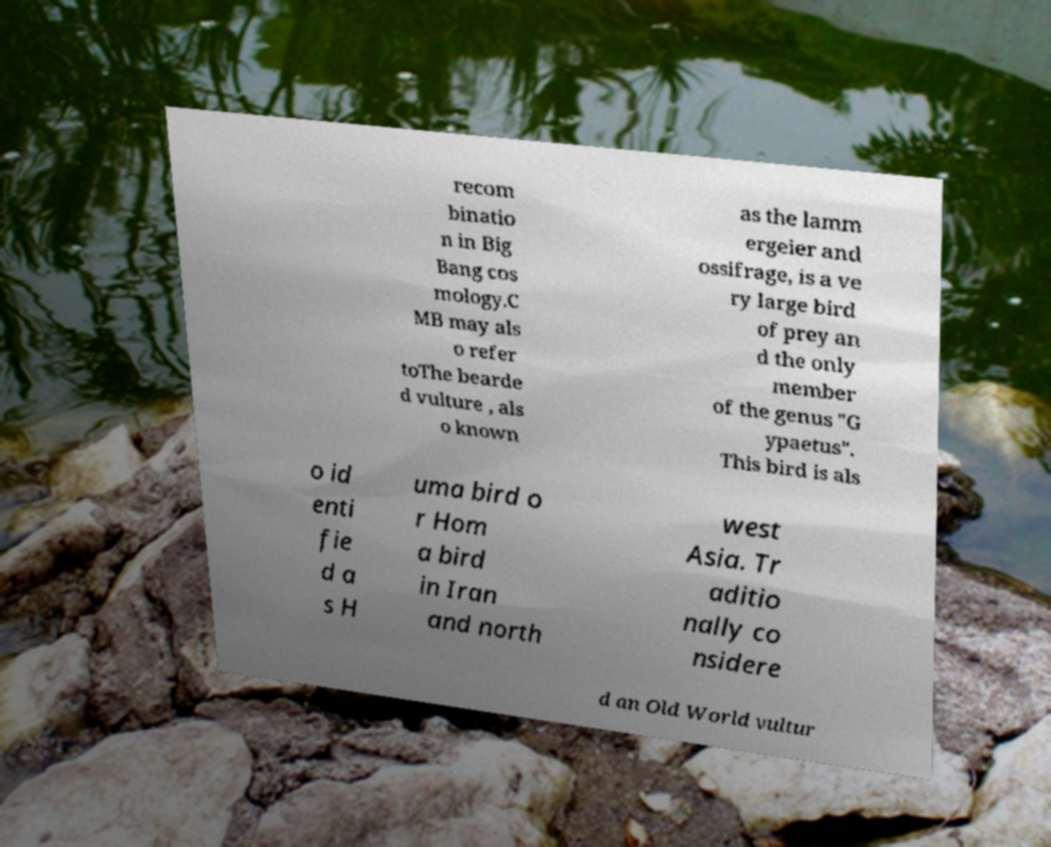What messages or text are displayed in this image? I need them in a readable, typed format. recom binatio n in Big Bang cos mology.C MB may als o refer toThe bearde d vulture , als o known as the lamm ergeier and ossifrage, is a ve ry large bird of prey an d the only member of the genus "G ypaetus". This bird is als o id enti fie d a s H uma bird o r Hom a bird in Iran and north west Asia. Tr aditio nally co nsidere d an Old World vultur 